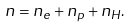<formula> <loc_0><loc_0><loc_500><loc_500>n = n _ { e } + n _ { p } + n _ { H } .</formula> 